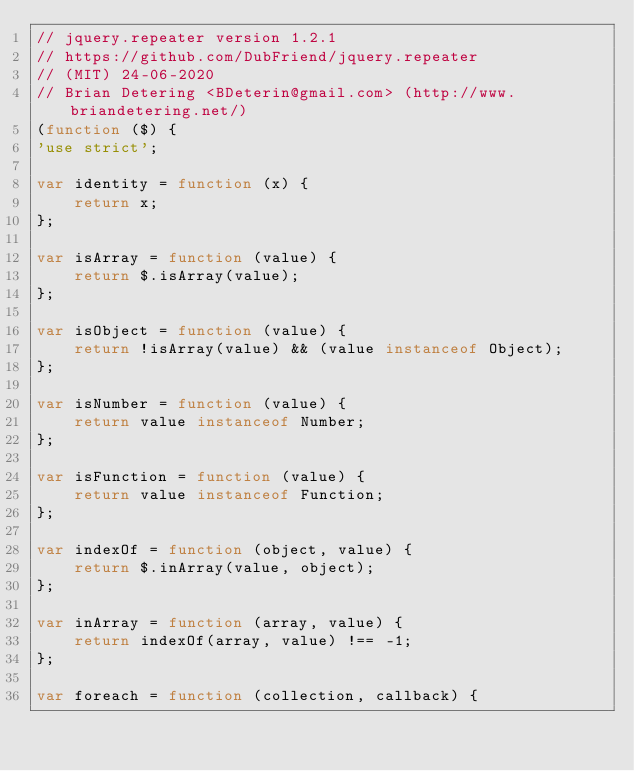Convert code to text. <code><loc_0><loc_0><loc_500><loc_500><_JavaScript_>// jquery.repeater version 1.2.1
// https://github.com/DubFriend/jquery.repeater
// (MIT) 24-06-2020
// Brian Detering <BDeterin@gmail.com> (http://www.briandetering.net/)
(function ($) {
'use strict';

var identity = function (x) {
    return x;
};

var isArray = function (value) {
    return $.isArray(value);
};

var isObject = function (value) {
    return !isArray(value) && (value instanceof Object);
};

var isNumber = function (value) {
    return value instanceof Number;
};

var isFunction = function (value) {
    return value instanceof Function;
};

var indexOf = function (object, value) {
    return $.inArray(value, object);
};

var inArray = function (array, value) {
    return indexOf(array, value) !== -1;
};

var foreach = function (collection, callback) {</code> 